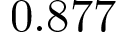<formula> <loc_0><loc_0><loc_500><loc_500>0 . 8 7 7</formula> 